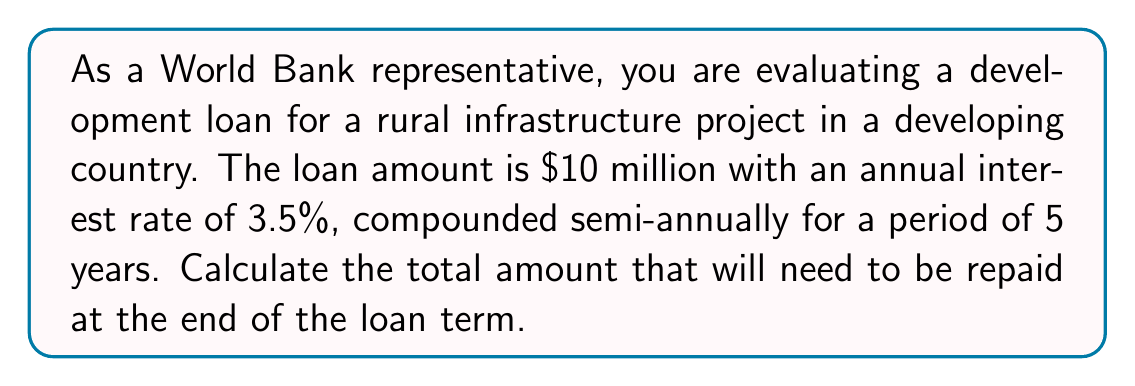What is the answer to this math problem? To solve this problem, we'll use the compound interest formula:

$$A = P(1 + \frac{r}{n})^{nt}$$

Where:
$A$ = Final amount
$P$ = Principal (initial loan amount)
$r$ = Annual interest rate (as a decimal)
$n$ = Number of times interest is compounded per year
$t$ = Number of years

Given:
$P = \$10,000,000$
$r = 0.035$ (3.5% as a decimal)
$n = 2$ (compounded semi-annually)
$t = 5$ years

Let's substitute these values into the formula:

$$A = 10,000,000(1 + \frac{0.035}{2})^{2(5)}$$

$$A = 10,000,000(1 + 0.0175)^{10}$$

$$A = 10,000,000(1.0175)^{10}$$

Using a calculator or computer:

$$A = 10,000,000 * 1.1889634$$

$$A = 11,889,634.35$$
Answer: $11,889,634.35 